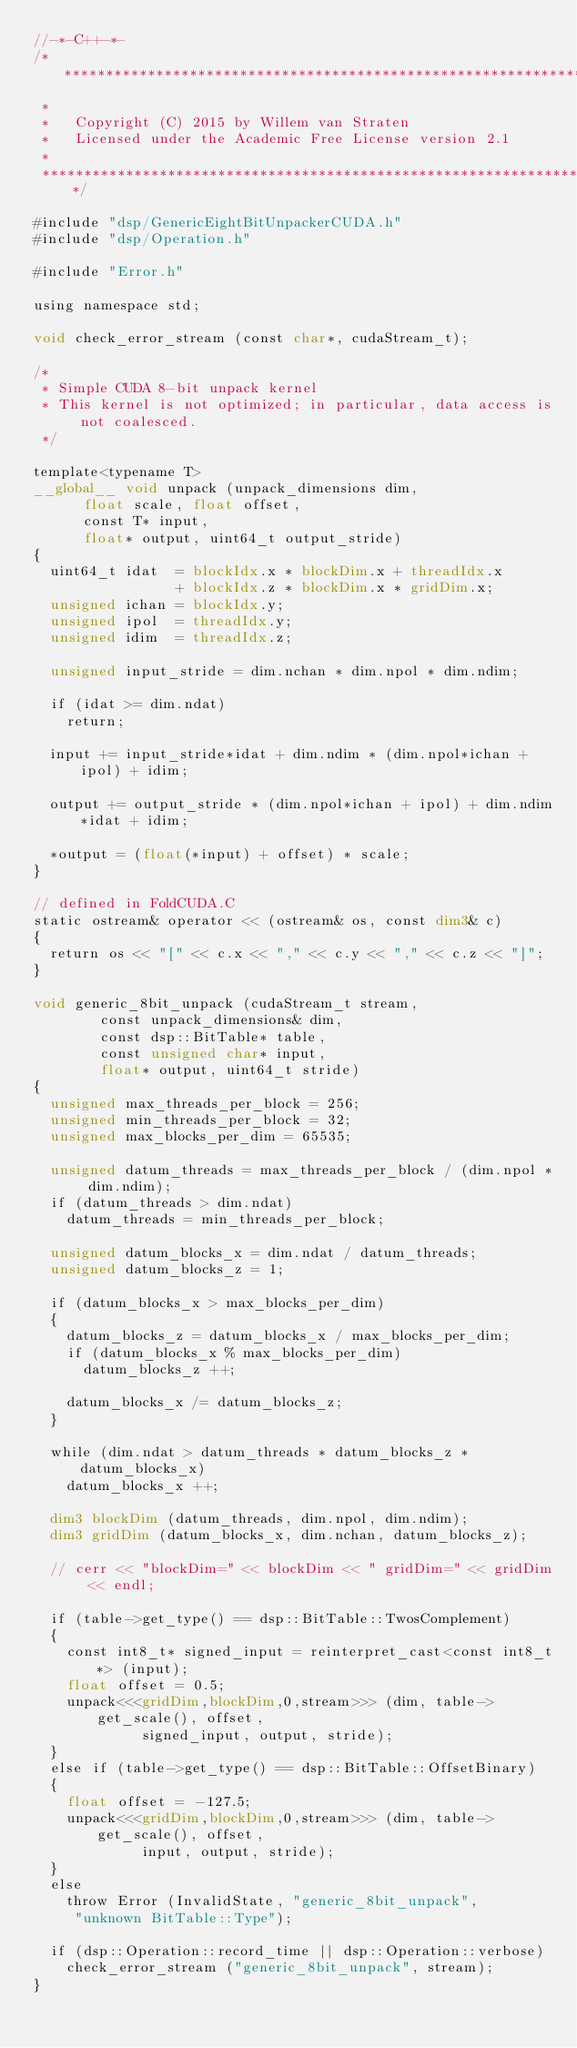<code> <loc_0><loc_0><loc_500><loc_500><_Cuda_>//-*-C++-*-
/***************************************************************************
 *
 *   Copyright (C) 2015 by Willem van Straten
 *   Licensed under the Academic Free License version 2.1
 *
 ***************************************************************************/

#include "dsp/GenericEightBitUnpackerCUDA.h"
#include "dsp/Operation.h"

#include "Error.h"

using namespace std;

void check_error_stream (const char*, cudaStream_t);

/*
 * Simple CUDA 8-bit unpack kernel
 * This kernel is not optimized; in particular, data access is not coalesced.
 */

template<typename T>
__global__ void unpack (unpack_dimensions dim,
			float scale, float offset,
			const T* input,
			float* output, uint64_t output_stride)
{
  uint64_t idat  = blockIdx.x * blockDim.x + threadIdx.x
                 + blockIdx.z * blockDim.x * gridDim.x;
  unsigned ichan = blockIdx.y;
  unsigned ipol  = threadIdx.y;
  unsigned idim  = threadIdx.z;

  unsigned input_stride = dim.nchan * dim.npol * dim.ndim;

  if (idat >= dim.ndat)
    return;

  input += input_stride*idat + dim.ndim * (dim.npol*ichan + ipol) + idim;

  output += output_stride * (dim.npol*ichan + ipol) + dim.ndim*idat + idim;

  *output = (float(*input) + offset) * scale;
}

// defined in FoldCUDA.C
static ostream& operator << (ostream& os, const dim3& c)
{
  return os << "[" << c.x << "," << c.y << "," << c.z << "]";
}

void generic_8bit_unpack (cudaStream_t stream, 
			  const unpack_dimensions& dim,
			  const dsp::BitTable* table,
			  const unsigned char* input,
			  float* output, uint64_t stride)
{
  unsigned max_threads_per_block = 256;
  unsigned min_threads_per_block = 32;
  unsigned max_blocks_per_dim = 65535;

  unsigned datum_threads = max_threads_per_block / (dim.npol * dim.ndim);
  if (datum_threads > dim.ndat)
    datum_threads = min_threads_per_block;

  unsigned datum_blocks_x = dim.ndat / datum_threads;
  unsigned datum_blocks_z = 1;

  if (datum_blocks_x > max_blocks_per_dim)
  {
    datum_blocks_z = datum_blocks_x / max_blocks_per_dim;
    if (datum_blocks_x % max_blocks_per_dim)
      datum_blocks_z ++;

    datum_blocks_x /= datum_blocks_z;
  }

  while (dim.ndat > datum_threads * datum_blocks_z * datum_blocks_x)
    datum_blocks_x ++;

  dim3 blockDim (datum_threads, dim.npol, dim.ndim);
  dim3 gridDim (datum_blocks_x, dim.nchan, datum_blocks_z);

  // cerr << "blockDim=" << blockDim << " gridDim=" << gridDim << endl;

  if (table->get_type() == dsp::BitTable::TwosComplement)
  {
    const int8_t* signed_input = reinterpret_cast<const int8_t*> (input);
    float offset = 0.5;
    unpack<<<gridDim,blockDim,0,stream>>> (dim, table->get_scale(), offset, 
					   signed_input, output, stride);
  }
  else if (table->get_type() == dsp::BitTable::OffsetBinary)
  {
    float offset = -127.5;
    unpack<<<gridDim,blockDim,0,stream>>> (dim, table->get_scale(), offset, 
					   input, output, stride);
  }
  else
    throw Error (InvalidState, "generic_8bit_unpack",
		 "unknown BitTable::Type");

  if (dsp::Operation::record_time || dsp::Operation::verbose)
    check_error_stream ("generic_8bit_unpack", stream);
}

</code> 